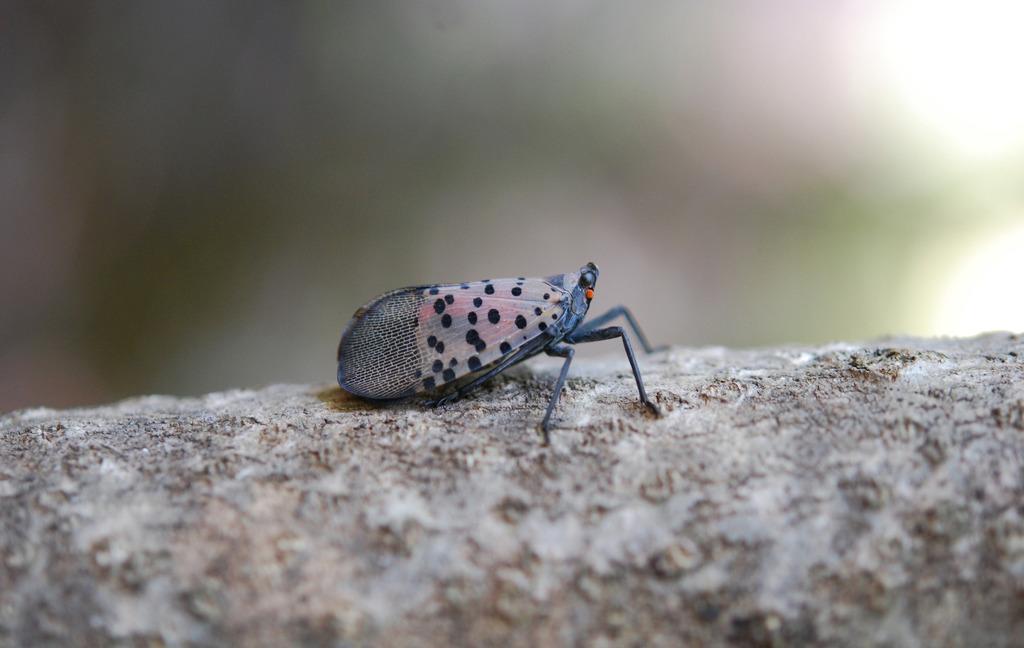How would you summarize this image in a sentence or two? In this image, I can see an insect on an object. There is a blurred background. 